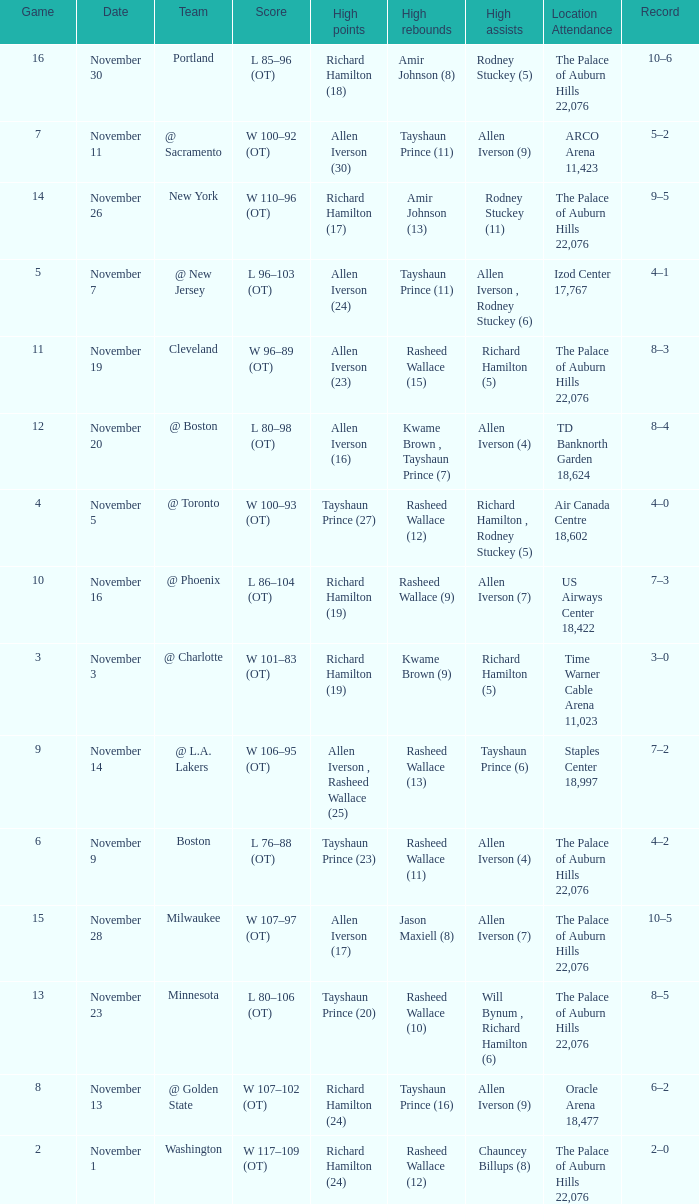What is Location Attendance, when High Points is "Allen Iverson (23)"? The Palace of Auburn Hills 22,076. 